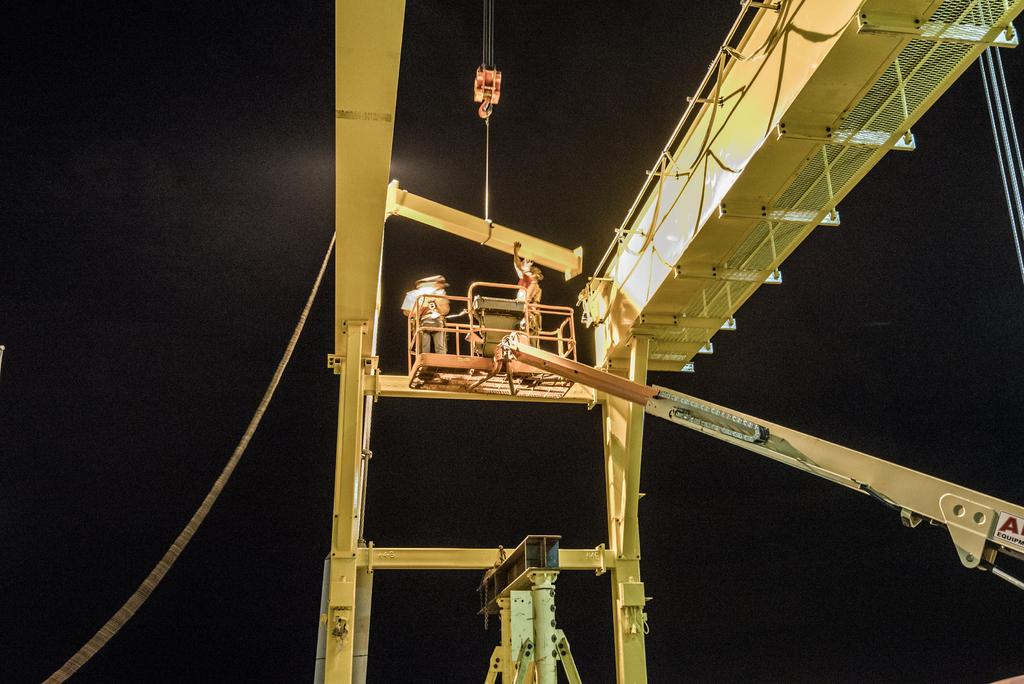What is the main subject of the image? The main subject of the image is a crane. Are there any other elements in the image besides the crane? Yes, there are people and metal rods visible in the image. What is the color of the background in the image? The background of the image is dark. What type of pollution can be seen in the image? There is no pollution visible in the image; it features a crane, people, and metal rods against a dark background. Can you tell me what request the people in the image are making? There is no indication of a request being made in the image; the people are simply present alongside the crane and metal rods. 